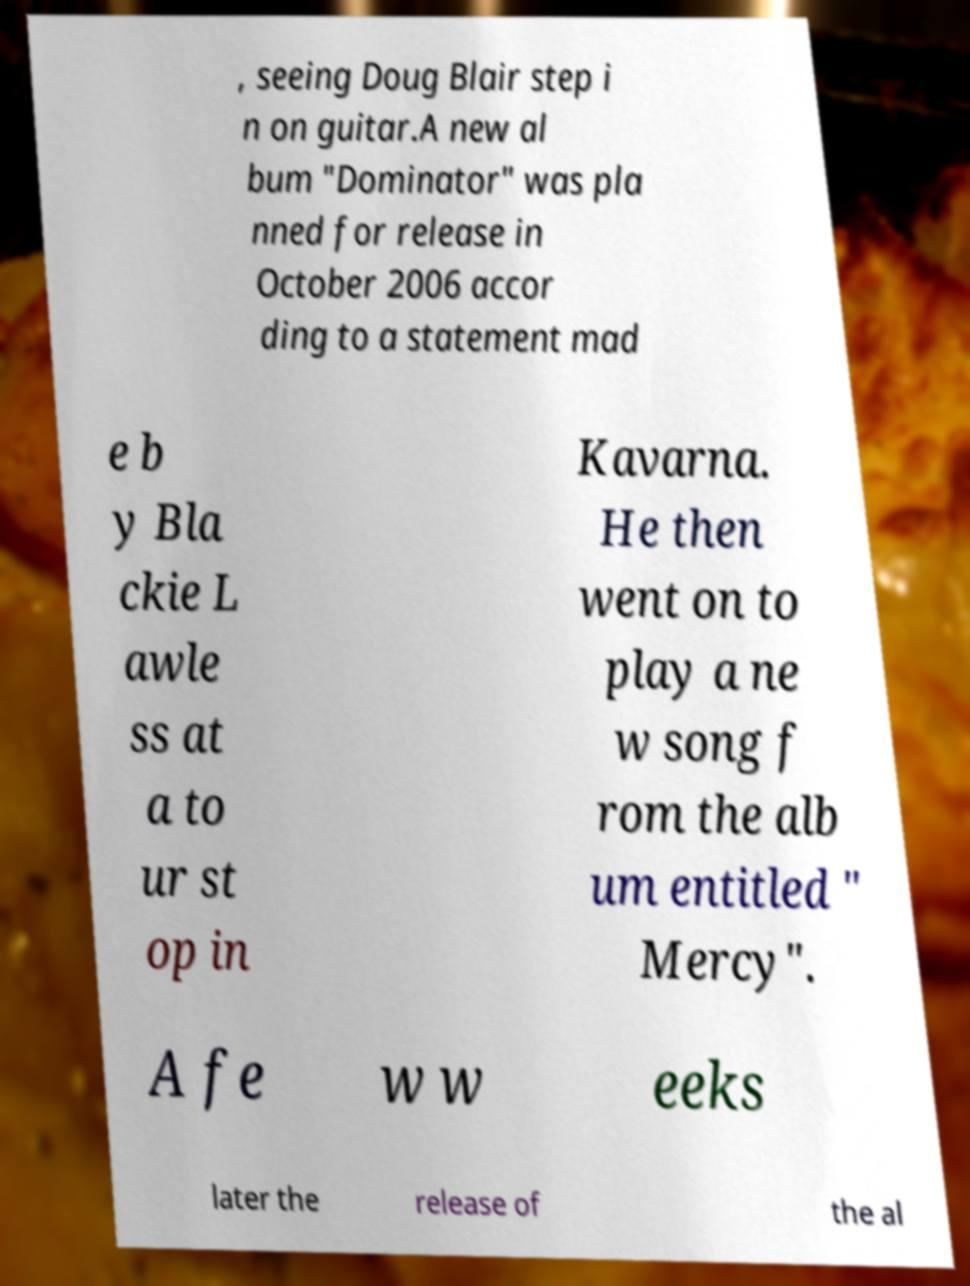What messages or text are displayed in this image? I need them in a readable, typed format. , seeing Doug Blair step i n on guitar.A new al bum "Dominator" was pla nned for release in October 2006 accor ding to a statement mad e b y Bla ckie L awle ss at a to ur st op in Kavarna. He then went on to play a ne w song f rom the alb um entitled " Mercy". A fe w w eeks later the release of the al 